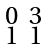Convert formula to latex. <formula><loc_0><loc_0><loc_500><loc_500>\begin{smallmatrix} 0 & 3 \\ 1 & 1 \end{smallmatrix}</formula> 